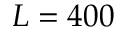Convert formula to latex. <formula><loc_0><loc_0><loc_500><loc_500>L = 4 0 0</formula> 